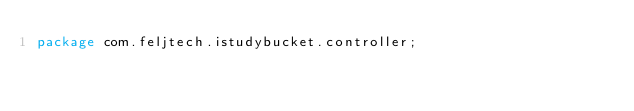<code> <loc_0><loc_0><loc_500><loc_500><_Java_>package com.feljtech.istudybucket.controller;
</code> 